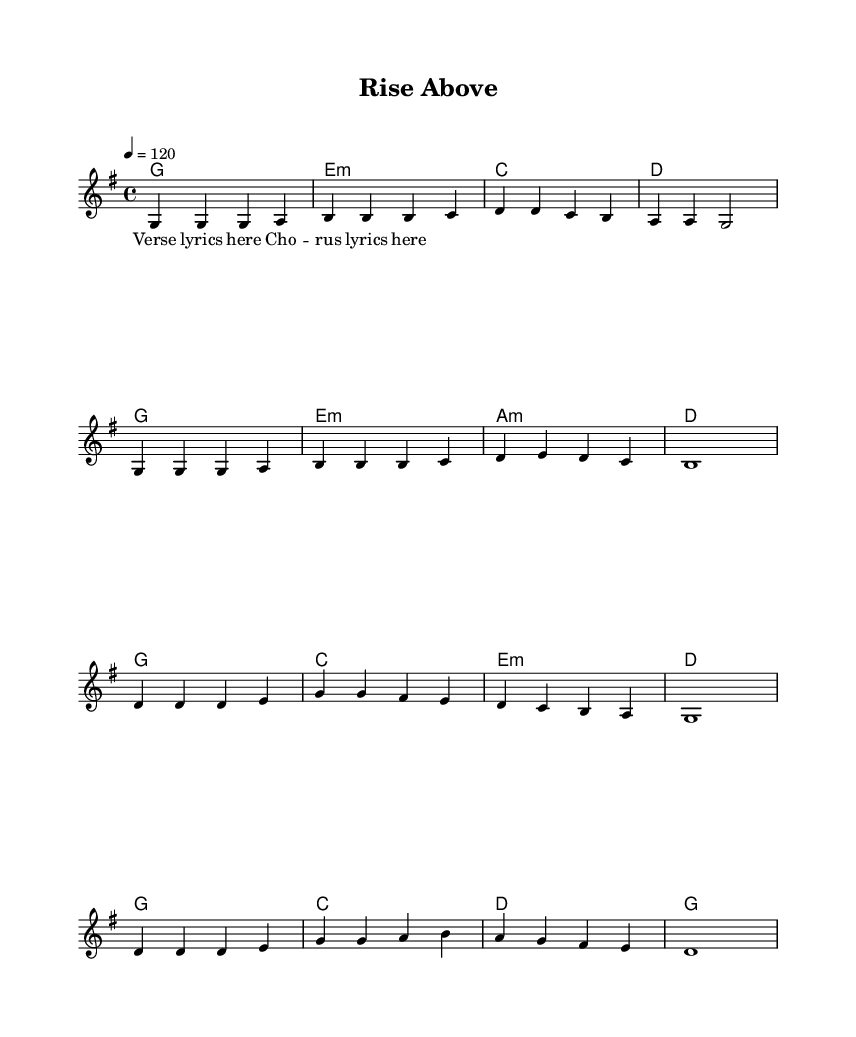What is the key signature of this music? The key signature is indicated by the sharps or flats at the beginning of the staff. Since there are no sharps or flats shown, the music is in G major, which has one sharp (F sharp).
Answer: G major What is the time signature of this music? The time signature is displayed at the beginning of the staff. Here, it is represented as "4/4," meaning there are four beats in each measure and the quarter note gets one beat.
Answer: 4/4 What is the tempo marking for this piece? The tempo is indicated at the start, where it states "4 = 120." This means that the quarter note should be played at a speed of 120 beats per minute.
Answer: 120 What is the first chord in the verse? To find the first chord, we look at the harmonies corresponding with the melody. The first chord is shown under the melody on the first staff, which is G major.
Answer: G How many measures are in the chorus? We count the number of measures in the chorus section indicated in the melody and harmonies. There are four measures repeated in the chorus part of the song.
Answer: Four Which section features the lyrics “Verse lyrics here”? The lyrics are structured under the melody, and the line stating “Verse lyrics here” is at the beginning of the verse section.
Answer: Verse 